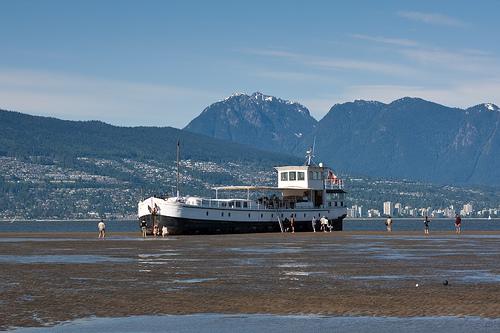Is this picture taken in the city?
Short answer required. No. Are these people planning to go on a boat ride?
Concise answer only. Yes. Is this boat stuck in mud?
Be succinct. Yes. 